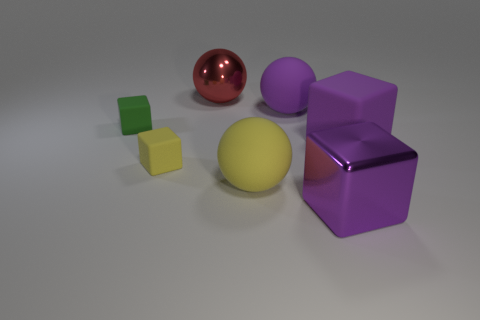What is the material of the ball that is the same color as the large metal block?
Your answer should be very brief. Rubber. Is the number of large blue metal cylinders greater than the number of shiny spheres?
Your response must be concise. No. The green matte object that is the same shape as the tiny yellow rubber thing is what size?
Provide a short and direct response. Small. Is the material of the green thing the same as the small yellow cube that is to the left of the purple ball?
Your response must be concise. Yes. What number of objects are either brown metallic balls or tiny yellow rubber objects?
Provide a short and direct response. 1. Is the size of the metallic object that is behind the yellow rubber sphere the same as the yellow cube that is in front of the red metallic thing?
Provide a succinct answer. No. What number of spheres are yellow objects or big red things?
Offer a very short reply. 2. Is there a tiny brown ball?
Ensure brevity in your answer.  No. Is there anything else that is the same shape as the big red object?
Keep it short and to the point. Yes. Is the big metal cube the same color as the shiny ball?
Offer a terse response. No. 